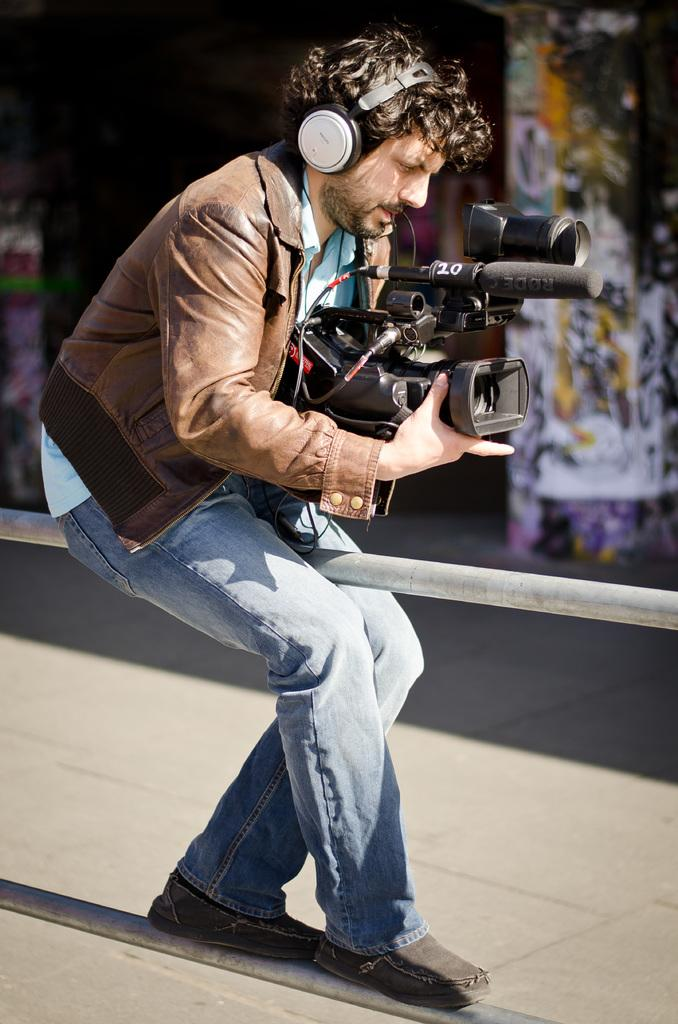What is the man holding in the image? The man is holding a camera. What is the man wearing on his head? The man is wearing a headset. In which direction is the man facing? The man is facing towards the right side of the image. What type of ink is the man using to write on the bikes in the image? There are no bikes or ink present in the image; the man is holding a camera and wearing a headset. 